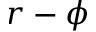Convert formula to latex. <formula><loc_0><loc_0><loc_500><loc_500>r - \phi</formula> 